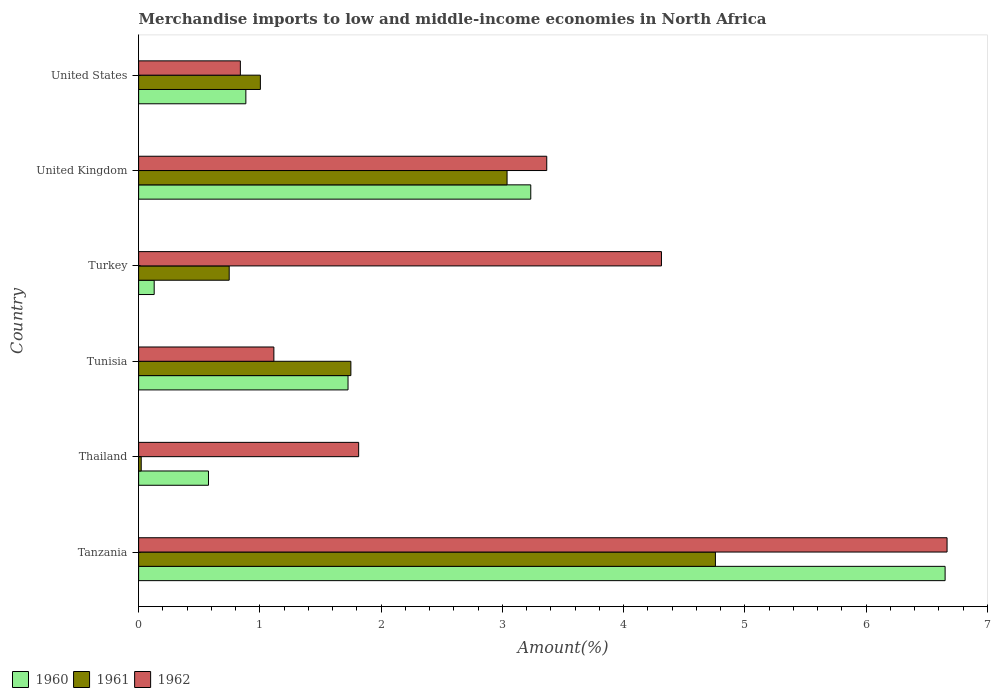How many groups of bars are there?
Make the answer very short. 6. Are the number of bars per tick equal to the number of legend labels?
Your response must be concise. Yes. Are the number of bars on each tick of the Y-axis equal?
Make the answer very short. Yes. How many bars are there on the 6th tick from the top?
Offer a terse response. 3. How many bars are there on the 5th tick from the bottom?
Make the answer very short. 3. What is the label of the 5th group of bars from the top?
Keep it short and to the point. Thailand. In how many cases, is the number of bars for a given country not equal to the number of legend labels?
Keep it short and to the point. 0. What is the percentage of amount earned from merchandise imports in 1961 in Turkey?
Offer a very short reply. 0.75. Across all countries, what is the maximum percentage of amount earned from merchandise imports in 1960?
Offer a very short reply. 6.65. Across all countries, what is the minimum percentage of amount earned from merchandise imports in 1961?
Keep it short and to the point. 0.02. In which country was the percentage of amount earned from merchandise imports in 1960 maximum?
Give a very brief answer. Tanzania. In which country was the percentage of amount earned from merchandise imports in 1962 minimum?
Ensure brevity in your answer.  United States. What is the total percentage of amount earned from merchandise imports in 1960 in the graph?
Your answer should be compact. 13.2. What is the difference between the percentage of amount earned from merchandise imports in 1961 in Tanzania and that in United Kingdom?
Your response must be concise. 1.72. What is the difference between the percentage of amount earned from merchandise imports in 1962 in United Kingdom and the percentage of amount earned from merchandise imports in 1960 in Tanzania?
Ensure brevity in your answer.  -3.29. What is the average percentage of amount earned from merchandise imports in 1961 per country?
Your response must be concise. 1.89. What is the difference between the percentage of amount earned from merchandise imports in 1960 and percentage of amount earned from merchandise imports in 1961 in United Kingdom?
Give a very brief answer. 0.2. In how many countries, is the percentage of amount earned from merchandise imports in 1960 greater than 4.4 %?
Provide a succinct answer. 1. What is the ratio of the percentage of amount earned from merchandise imports in 1962 in Thailand to that in Tunisia?
Your answer should be very brief. 1.63. Is the percentage of amount earned from merchandise imports in 1960 in Tanzania less than that in Turkey?
Provide a succinct answer. No. What is the difference between the highest and the second highest percentage of amount earned from merchandise imports in 1961?
Keep it short and to the point. 1.72. What is the difference between the highest and the lowest percentage of amount earned from merchandise imports in 1961?
Provide a succinct answer. 4.74. In how many countries, is the percentage of amount earned from merchandise imports in 1962 greater than the average percentage of amount earned from merchandise imports in 1962 taken over all countries?
Ensure brevity in your answer.  3. What does the 1st bar from the top in United States represents?
Your answer should be very brief. 1962. What does the 3rd bar from the bottom in Tanzania represents?
Offer a terse response. 1962. Is it the case that in every country, the sum of the percentage of amount earned from merchandise imports in 1961 and percentage of amount earned from merchandise imports in 1960 is greater than the percentage of amount earned from merchandise imports in 1962?
Your answer should be compact. No. Are the values on the major ticks of X-axis written in scientific E-notation?
Make the answer very short. No. Does the graph contain any zero values?
Your answer should be very brief. No. How many legend labels are there?
Give a very brief answer. 3. How are the legend labels stacked?
Give a very brief answer. Horizontal. What is the title of the graph?
Provide a short and direct response. Merchandise imports to low and middle-income economies in North Africa. Does "1984" appear as one of the legend labels in the graph?
Make the answer very short. No. What is the label or title of the X-axis?
Ensure brevity in your answer.  Amount(%). What is the Amount(%) in 1960 in Tanzania?
Provide a short and direct response. 6.65. What is the Amount(%) of 1961 in Tanzania?
Your answer should be very brief. 4.76. What is the Amount(%) in 1962 in Tanzania?
Offer a terse response. 6.67. What is the Amount(%) of 1960 in Thailand?
Your answer should be compact. 0.58. What is the Amount(%) in 1961 in Thailand?
Keep it short and to the point. 0.02. What is the Amount(%) of 1962 in Thailand?
Provide a short and direct response. 1.81. What is the Amount(%) in 1960 in Tunisia?
Give a very brief answer. 1.73. What is the Amount(%) of 1961 in Tunisia?
Make the answer very short. 1.75. What is the Amount(%) in 1962 in Tunisia?
Provide a succinct answer. 1.12. What is the Amount(%) of 1960 in Turkey?
Provide a short and direct response. 0.13. What is the Amount(%) in 1961 in Turkey?
Your response must be concise. 0.75. What is the Amount(%) of 1962 in Turkey?
Make the answer very short. 4.31. What is the Amount(%) of 1960 in United Kingdom?
Keep it short and to the point. 3.23. What is the Amount(%) in 1961 in United Kingdom?
Give a very brief answer. 3.04. What is the Amount(%) of 1962 in United Kingdom?
Give a very brief answer. 3.37. What is the Amount(%) of 1960 in United States?
Offer a terse response. 0.88. What is the Amount(%) in 1961 in United States?
Provide a short and direct response. 1. What is the Amount(%) of 1962 in United States?
Provide a succinct answer. 0.84. Across all countries, what is the maximum Amount(%) of 1960?
Your response must be concise. 6.65. Across all countries, what is the maximum Amount(%) of 1961?
Provide a short and direct response. 4.76. Across all countries, what is the maximum Amount(%) in 1962?
Provide a short and direct response. 6.67. Across all countries, what is the minimum Amount(%) of 1960?
Offer a very short reply. 0.13. Across all countries, what is the minimum Amount(%) in 1961?
Provide a succinct answer. 0.02. Across all countries, what is the minimum Amount(%) in 1962?
Offer a very short reply. 0.84. What is the total Amount(%) in 1960 in the graph?
Your response must be concise. 13.2. What is the total Amount(%) of 1961 in the graph?
Your answer should be compact. 11.32. What is the total Amount(%) in 1962 in the graph?
Offer a terse response. 18.11. What is the difference between the Amount(%) in 1960 in Tanzania and that in Thailand?
Offer a very short reply. 6.07. What is the difference between the Amount(%) in 1961 in Tanzania and that in Thailand?
Your answer should be compact. 4.74. What is the difference between the Amount(%) of 1962 in Tanzania and that in Thailand?
Provide a succinct answer. 4.85. What is the difference between the Amount(%) of 1960 in Tanzania and that in Tunisia?
Offer a terse response. 4.92. What is the difference between the Amount(%) in 1961 in Tanzania and that in Tunisia?
Give a very brief answer. 3.01. What is the difference between the Amount(%) of 1962 in Tanzania and that in Tunisia?
Your response must be concise. 5.55. What is the difference between the Amount(%) of 1960 in Tanzania and that in Turkey?
Keep it short and to the point. 6.52. What is the difference between the Amount(%) of 1961 in Tanzania and that in Turkey?
Provide a succinct answer. 4.01. What is the difference between the Amount(%) in 1962 in Tanzania and that in Turkey?
Your answer should be compact. 2.36. What is the difference between the Amount(%) in 1960 in Tanzania and that in United Kingdom?
Make the answer very short. 3.42. What is the difference between the Amount(%) in 1961 in Tanzania and that in United Kingdom?
Make the answer very short. 1.72. What is the difference between the Amount(%) of 1962 in Tanzania and that in United Kingdom?
Provide a succinct answer. 3.3. What is the difference between the Amount(%) of 1960 in Tanzania and that in United States?
Your response must be concise. 5.77. What is the difference between the Amount(%) in 1961 in Tanzania and that in United States?
Provide a short and direct response. 3.75. What is the difference between the Amount(%) in 1962 in Tanzania and that in United States?
Your answer should be very brief. 5.83. What is the difference between the Amount(%) in 1960 in Thailand and that in Tunisia?
Make the answer very short. -1.15. What is the difference between the Amount(%) of 1961 in Thailand and that in Tunisia?
Ensure brevity in your answer.  -1.73. What is the difference between the Amount(%) in 1962 in Thailand and that in Tunisia?
Your answer should be compact. 0.7. What is the difference between the Amount(%) of 1960 in Thailand and that in Turkey?
Provide a short and direct response. 0.45. What is the difference between the Amount(%) in 1961 in Thailand and that in Turkey?
Make the answer very short. -0.73. What is the difference between the Amount(%) in 1962 in Thailand and that in Turkey?
Offer a terse response. -2.5. What is the difference between the Amount(%) of 1960 in Thailand and that in United Kingdom?
Offer a very short reply. -2.66. What is the difference between the Amount(%) of 1961 in Thailand and that in United Kingdom?
Offer a very short reply. -3.02. What is the difference between the Amount(%) of 1962 in Thailand and that in United Kingdom?
Your answer should be compact. -1.55. What is the difference between the Amount(%) of 1960 in Thailand and that in United States?
Give a very brief answer. -0.31. What is the difference between the Amount(%) in 1961 in Thailand and that in United States?
Offer a very short reply. -0.98. What is the difference between the Amount(%) of 1962 in Thailand and that in United States?
Your answer should be very brief. 0.98. What is the difference between the Amount(%) of 1960 in Tunisia and that in Turkey?
Your response must be concise. 1.6. What is the difference between the Amount(%) in 1962 in Tunisia and that in Turkey?
Provide a short and direct response. -3.2. What is the difference between the Amount(%) in 1960 in Tunisia and that in United Kingdom?
Provide a short and direct response. -1.51. What is the difference between the Amount(%) in 1961 in Tunisia and that in United Kingdom?
Keep it short and to the point. -1.29. What is the difference between the Amount(%) in 1962 in Tunisia and that in United Kingdom?
Ensure brevity in your answer.  -2.25. What is the difference between the Amount(%) of 1960 in Tunisia and that in United States?
Offer a terse response. 0.84. What is the difference between the Amount(%) in 1961 in Tunisia and that in United States?
Offer a very short reply. 0.75. What is the difference between the Amount(%) of 1962 in Tunisia and that in United States?
Your response must be concise. 0.28. What is the difference between the Amount(%) of 1960 in Turkey and that in United Kingdom?
Give a very brief answer. -3.11. What is the difference between the Amount(%) of 1961 in Turkey and that in United Kingdom?
Provide a short and direct response. -2.29. What is the difference between the Amount(%) in 1962 in Turkey and that in United Kingdom?
Make the answer very short. 0.95. What is the difference between the Amount(%) of 1960 in Turkey and that in United States?
Your answer should be very brief. -0.76. What is the difference between the Amount(%) in 1961 in Turkey and that in United States?
Offer a very short reply. -0.26. What is the difference between the Amount(%) in 1962 in Turkey and that in United States?
Offer a terse response. 3.47. What is the difference between the Amount(%) in 1960 in United Kingdom and that in United States?
Provide a succinct answer. 2.35. What is the difference between the Amount(%) of 1961 in United Kingdom and that in United States?
Your response must be concise. 2.03. What is the difference between the Amount(%) in 1962 in United Kingdom and that in United States?
Your answer should be very brief. 2.53. What is the difference between the Amount(%) of 1960 in Tanzania and the Amount(%) of 1961 in Thailand?
Make the answer very short. 6.63. What is the difference between the Amount(%) in 1960 in Tanzania and the Amount(%) in 1962 in Thailand?
Keep it short and to the point. 4.84. What is the difference between the Amount(%) in 1961 in Tanzania and the Amount(%) in 1962 in Thailand?
Give a very brief answer. 2.94. What is the difference between the Amount(%) in 1960 in Tanzania and the Amount(%) in 1961 in Tunisia?
Make the answer very short. 4.9. What is the difference between the Amount(%) of 1960 in Tanzania and the Amount(%) of 1962 in Tunisia?
Offer a terse response. 5.54. What is the difference between the Amount(%) in 1961 in Tanzania and the Amount(%) in 1962 in Tunisia?
Your answer should be very brief. 3.64. What is the difference between the Amount(%) in 1960 in Tanzania and the Amount(%) in 1961 in Turkey?
Make the answer very short. 5.9. What is the difference between the Amount(%) of 1960 in Tanzania and the Amount(%) of 1962 in Turkey?
Provide a short and direct response. 2.34. What is the difference between the Amount(%) in 1961 in Tanzania and the Amount(%) in 1962 in Turkey?
Provide a succinct answer. 0.45. What is the difference between the Amount(%) in 1960 in Tanzania and the Amount(%) in 1961 in United Kingdom?
Your response must be concise. 3.61. What is the difference between the Amount(%) in 1960 in Tanzania and the Amount(%) in 1962 in United Kingdom?
Your answer should be very brief. 3.29. What is the difference between the Amount(%) of 1961 in Tanzania and the Amount(%) of 1962 in United Kingdom?
Your answer should be compact. 1.39. What is the difference between the Amount(%) in 1960 in Tanzania and the Amount(%) in 1961 in United States?
Give a very brief answer. 5.65. What is the difference between the Amount(%) of 1960 in Tanzania and the Amount(%) of 1962 in United States?
Offer a very short reply. 5.81. What is the difference between the Amount(%) in 1961 in Tanzania and the Amount(%) in 1962 in United States?
Keep it short and to the point. 3.92. What is the difference between the Amount(%) of 1960 in Thailand and the Amount(%) of 1961 in Tunisia?
Offer a very short reply. -1.17. What is the difference between the Amount(%) in 1960 in Thailand and the Amount(%) in 1962 in Tunisia?
Give a very brief answer. -0.54. What is the difference between the Amount(%) in 1961 in Thailand and the Amount(%) in 1962 in Tunisia?
Give a very brief answer. -1.09. What is the difference between the Amount(%) of 1960 in Thailand and the Amount(%) of 1961 in Turkey?
Provide a short and direct response. -0.17. What is the difference between the Amount(%) of 1960 in Thailand and the Amount(%) of 1962 in Turkey?
Offer a terse response. -3.74. What is the difference between the Amount(%) of 1961 in Thailand and the Amount(%) of 1962 in Turkey?
Keep it short and to the point. -4.29. What is the difference between the Amount(%) in 1960 in Thailand and the Amount(%) in 1961 in United Kingdom?
Keep it short and to the point. -2.46. What is the difference between the Amount(%) of 1960 in Thailand and the Amount(%) of 1962 in United Kingdom?
Offer a very short reply. -2.79. What is the difference between the Amount(%) of 1961 in Thailand and the Amount(%) of 1962 in United Kingdom?
Give a very brief answer. -3.34. What is the difference between the Amount(%) in 1960 in Thailand and the Amount(%) in 1961 in United States?
Offer a terse response. -0.43. What is the difference between the Amount(%) in 1960 in Thailand and the Amount(%) in 1962 in United States?
Your response must be concise. -0.26. What is the difference between the Amount(%) in 1961 in Thailand and the Amount(%) in 1962 in United States?
Offer a very short reply. -0.82. What is the difference between the Amount(%) of 1960 in Tunisia and the Amount(%) of 1962 in Turkey?
Offer a very short reply. -2.58. What is the difference between the Amount(%) in 1961 in Tunisia and the Amount(%) in 1962 in Turkey?
Your response must be concise. -2.56. What is the difference between the Amount(%) in 1960 in Tunisia and the Amount(%) in 1961 in United Kingdom?
Your answer should be compact. -1.31. What is the difference between the Amount(%) in 1960 in Tunisia and the Amount(%) in 1962 in United Kingdom?
Give a very brief answer. -1.64. What is the difference between the Amount(%) of 1961 in Tunisia and the Amount(%) of 1962 in United Kingdom?
Your response must be concise. -1.62. What is the difference between the Amount(%) in 1960 in Tunisia and the Amount(%) in 1961 in United States?
Offer a terse response. 0.72. What is the difference between the Amount(%) in 1960 in Tunisia and the Amount(%) in 1962 in United States?
Your answer should be very brief. 0.89. What is the difference between the Amount(%) in 1961 in Tunisia and the Amount(%) in 1962 in United States?
Your answer should be very brief. 0.91. What is the difference between the Amount(%) of 1960 in Turkey and the Amount(%) of 1961 in United Kingdom?
Make the answer very short. -2.91. What is the difference between the Amount(%) in 1960 in Turkey and the Amount(%) in 1962 in United Kingdom?
Provide a short and direct response. -3.24. What is the difference between the Amount(%) in 1961 in Turkey and the Amount(%) in 1962 in United Kingdom?
Give a very brief answer. -2.62. What is the difference between the Amount(%) of 1960 in Turkey and the Amount(%) of 1961 in United States?
Provide a short and direct response. -0.88. What is the difference between the Amount(%) in 1960 in Turkey and the Amount(%) in 1962 in United States?
Ensure brevity in your answer.  -0.71. What is the difference between the Amount(%) in 1961 in Turkey and the Amount(%) in 1962 in United States?
Your answer should be very brief. -0.09. What is the difference between the Amount(%) in 1960 in United Kingdom and the Amount(%) in 1961 in United States?
Provide a short and direct response. 2.23. What is the difference between the Amount(%) in 1960 in United Kingdom and the Amount(%) in 1962 in United States?
Your answer should be very brief. 2.39. What is the difference between the Amount(%) in 1961 in United Kingdom and the Amount(%) in 1962 in United States?
Your response must be concise. 2.2. What is the average Amount(%) in 1960 per country?
Provide a short and direct response. 2.2. What is the average Amount(%) in 1961 per country?
Keep it short and to the point. 1.89. What is the average Amount(%) of 1962 per country?
Make the answer very short. 3.02. What is the difference between the Amount(%) in 1960 and Amount(%) in 1961 in Tanzania?
Provide a short and direct response. 1.89. What is the difference between the Amount(%) of 1960 and Amount(%) of 1962 in Tanzania?
Ensure brevity in your answer.  -0.02. What is the difference between the Amount(%) of 1961 and Amount(%) of 1962 in Tanzania?
Give a very brief answer. -1.91. What is the difference between the Amount(%) of 1960 and Amount(%) of 1961 in Thailand?
Make the answer very short. 0.55. What is the difference between the Amount(%) in 1960 and Amount(%) in 1962 in Thailand?
Provide a succinct answer. -1.24. What is the difference between the Amount(%) in 1961 and Amount(%) in 1962 in Thailand?
Your answer should be compact. -1.79. What is the difference between the Amount(%) in 1960 and Amount(%) in 1961 in Tunisia?
Keep it short and to the point. -0.02. What is the difference between the Amount(%) of 1960 and Amount(%) of 1962 in Tunisia?
Give a very brief answer. 0.61. What is the difference between the Amount(%) of 1961 and Amount(%) of 1962 in Tunisia?
Provide a succinct answer. 0.64. What is the difference between the Amount(%) in 1960 and Amount(%) in 1961 in Turkey?
Make the answer very short. -0.62. What is the difference between the Amount(%) of 1960 and Amount(%) of 1962 in Turkey?
Make the answer very short. -4.18. What is the difference between the Amount(%) of 1961 and Amount(%) of 1962 in Turkey?
Your response must be concise. -3.56. What is the difference between the Amount(%) in 1960 and Amount(%) in 1961 in United Kingdom?
Your response must be concise. 0.2. What is the difference between the Amount(%) of 1960 and Amount(%) of 1962 in United Kingdom?
Give a very brief answer. -0.13. What is the difference between the Amount(%) of 1961 and Amount(%) of 1962 in United Kingdom?
Offer a terse response. -0.33. What is the difference between the Amount(%) in 1960 and Amount(%) in 1961 in United States?
Provide a succinct answer. -0.12. What is the difference between the Amount(%) of 1960 and Amount(%) of 1962 in United States?
Your answer should be very brief. 0.05. What is the difference between the Amount(%) of 1961 and Amount(%) of 1962 in United States?
Your answer should be very brief. 0.17. What is the ratio of the Amount(%) in 1960 in Tanzania to that in Thailand?
Offer a terse response. 11.55. What is the ratio of the Amount(%) of 1961 in Tanzania to that in Thailand?
Your response must be concise. 222.79. What is the ratio of the Amount(%) of 1962 in Tanzania to that in Thailand?
Provide a short and direct response. 3.67. What is the ratio of the Amount(%) in 1960 in Tanzania to that in Tunisia?
Ensure brevity in your answer.  3.85. What is the ratio of the Amount(%) in 1961 in Tanzania to that in Tunisia?
Make the answer very short. 2.72. What is the ratio of the Amount(%) in 1962 in Tanzania to that in Tunisia?
Give a very brief answer. 5.98. What is the ratio of the Amount(%) in 1960 in Tanzania to that in Turkey?
Keep it short and to the point. 51.84. What is the ratio of the Amount(%) of 1961 in Tanzania to that in Turkey?
Keep it short and to the point. 6.37. What is the ratio of the Amount(%) in 1962 in Tanzania to that in Turkey?
Offer a terse response. 1.55. What is the ratio of the Amount(%) in 1960 in Tanzania to that in United Kingdom?
Provide a short and direct response. 2.06. What is the ratio of the Amount(%) in 1961 in Tanzania to that in United Kingdom?
Offer a terse response. 1.57. What is the ratio of the Amount(%) in 1962 in Tanzania to that in United Kingdom?
Ensure brevity in your answer.  1.98. What is the ratio of the Amount(%) in 1960 in Tanzania to that in United States?
Ensure brevity in your answer.  7.52. What is the ratio of the Amount(%) in 1961 in Tanzania to that in United States?
Offer a terse response. 4.74. What is the ratio of the Amount(%) in 1962 in Tanzania to that in United States?
Keep it short and to the point. 7.95. What is the ratio of the Amount(%) of 1960 in Thailand to that in Tunisia?
Offer a terse response. 0.33. What is the ratio of the Amount(%) of 1961 in Thailand to that in Tunisia?
Your answer should be very brief. 0.01. What is the ratio of the Amount(%) of 1962 in Thailand to that in Tunisia?
Ensure brevity in your answer.  1.63. What is the ratio of the Amount(%) in 1960 in Thailand to that in Turkey?
Your response must be concise. 4.49. What is the ratio of the Amount(%) in 1961 in Thailand to that in Turkey?
Make the answer very short. 0.03. What is the ratio of the Amount(%) in 1962 in Thailand to that in Turkey?
Provide a short and direct response. 0.42. What is the ratio of the Amount(%) of 1960 in Thailand to that in United Kingdom?
Give a very brief answer. 0.18. What is the ratio of the Amount(%) of 1961 in Thailand to that in United Kingdom?
Your answer should be compact. 0.01. What is the ratio of the Amount(%) of 1962 in Thailand to that in United Kingdom?
Make the answer very short. 0.54. What is the ratio of the Amount(%) in 1960 in Thailand to that in United States?
Your response must be concise. 0.65. What is the ratio of the Amount(%) in 1961 in Thailand to that in United States?
Provide a succinct answer. 0.02. What is the ratio of the Amount(%) of 1962 in Thailand to that in United States?
Your answer should be very brief. 2.16. What is the ratio of the Amount(%) of 1960 in Tunisia to that in Turkey?
Your answer should be very brief. 13.46. What is the ratio of the Amount(%) in 1961 in Tunisia to that in Turkey?
Keep it short and to the point. 2.34. What is the ratio of the Amount(%) of 1962 in Tunisia to that in Turkey?
Offer a very short reply. 0.26. What is the ratio of the Amount(%) of 1960 in Tunisia to that in United Kingdom?
Your answer should be compact. 0.53. What is the ratio of the Amount(%) in 1961 in Tunisia to that in United Kingdom?
Offer a very short reply. 0.58. What is the ratio of the Amount(%) of 1962 in Tunisia to that in United Kingdom?
Keep it short and to the point. 0.33. What is the ratio of the Amount(%) in 1960 in Tunisia to that in United States?
Your answer should be very brief. 1.95. What is the ratio of the Amount(%) in 1961 in Tunisia to that in United States?
Your response must be concise. 1.74. What is the ratio of the Amount(%) in 1962 in Tunisia to that in United States?
Your answer should be very brief. 1.33. What is the ratio of the Amount(%) of 1960 in Turkey to that in United Kingdom?
Keep it short and to the point. 0.04. What is the ratio of the Amount(%) in 1961 in Turkey to that in United Kingdom?
Ensure brevity in your answer.  0.25. What is the ratio of the Amount(%) in 1962 in Turkey to that in United Kingdom?
Offer a terse response. 1.28. What is the ratio of the Amount(%) of 1960 in Turkey to that in United States?
Offer a terse response. 0.15. What is the ratio of the Amount(%) in 1961 in Turkey to that in United States?
Your answer should be very brief. 0.74. What is the ratio of the Amount(%) of 1962 in Turkey to that in United States?
Provide a succinct answer. 5.14. What is the ratio of the Amount(%) in 1960 in United Kingdom to that in United States?
Ensure brevity in your answer.  3.66. What is the ratio of the Amount(%) of 1961 in United Kingdom to that in United States?
Your answer should be very brief. 3.03. What is the ratio of the Amount(%) in 1962 in United Kingdom to that in United States?
Your answer should be compact. 4.01. What is the difference between the highest and the second highest Amount(%) of 1960?
Provide a short and direct response. 3.42. What is the difference between the highest and the second highest Amount(%) in 1961?
Keep it short and to the point. 1.72. What is the difference between the highest and the second highest Amount(%) of 1962?
Ensure brevity in your answer.  2.36. What is the difference between the highest and the lowest Amount(%) in 1960?
Your response must be concise. 6.52. What is the difference between the highest and the lowest Amount(%) of 1961?
Offer a terse response. 4.74. What is the difference between the highest and the lowest Amount(%) of 1962?
Provide a short and direct response. 5.83. 